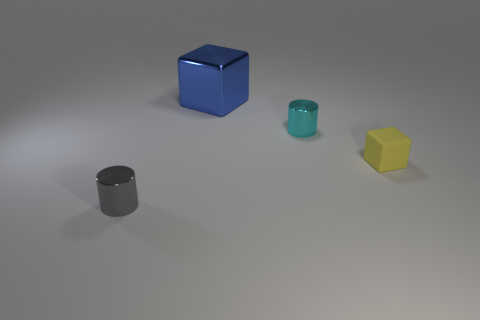Add 1 small brown matte balls. How many objects exist? 5 Subtract 1 cylinders. How many cylinders are left? 1 Subtract all yellow cubes. How many cubes are left? 1 Subtract all tiny shiny objects. Subtract all small shiny cylinders. How many objects are left? 0 Add 3 yellow rubber objects. How many yellow rubber objects are left? 4 Add 1 tiny gray matte balls. How many tiny gray matte balls exist? 1 Subtract 0 green cylinders. How many objects are left? 4 Subtract all red cylinders. Subtract all purple balls. How many cylinders are left? 2 